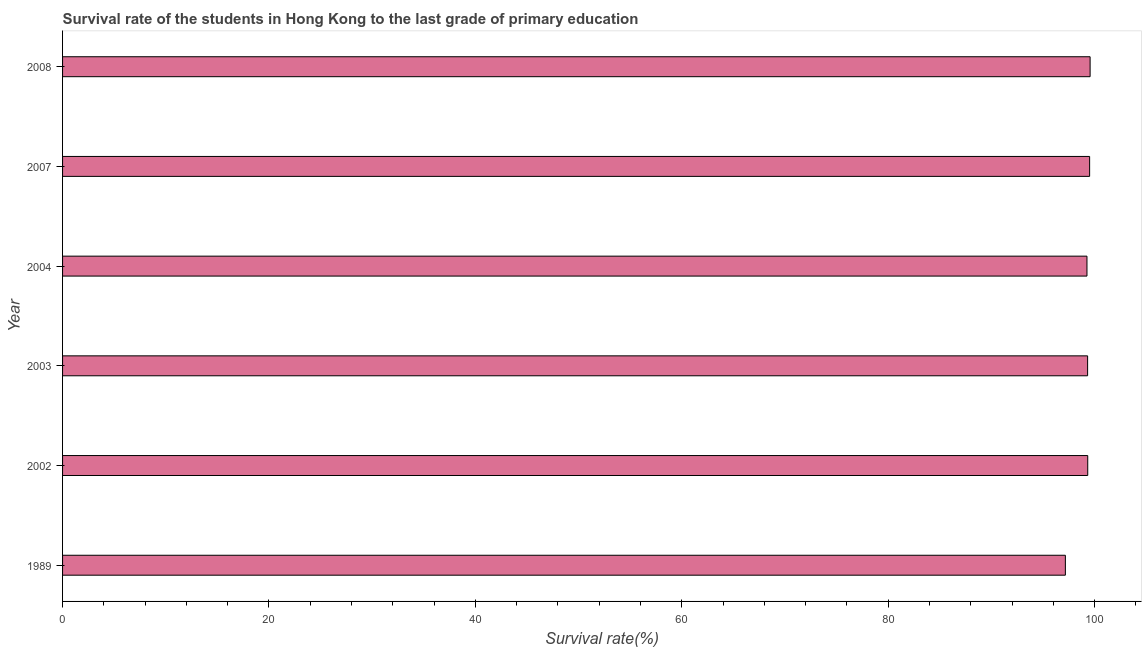Does the graph contain grids?
Provide a short and direct response. No. What is the title of the graph?
Offer a very short reply. Survival rate of the students in Hong Kong to the last grade of primary education. What is the label or title of the X-axis?
Your response must be concise. Survival rate(%). What is the survival rate in primary education in 2004?
Give a very brief answer. 99.26. Across all years, what is the maximum survival rate in primary education?
Offer a terse response. 99.56. Across all years, what is the minimum survival rate in primary education?
Your answer should be very brief. 97.16. In which year was the survival rate in primary education maximum?
Ensure brevity in your answer.  2008. What is the sum of the survival rate in primary education?
Ensure brevity in your answer.  594.14. What is the difference between the survival rate in primary education in 1989 and 2008?
Provide a succinct answer. -2.4. What is the average survival rate in primary education per year?
Make the answer very short. 99.02. What is the median survival rate in primary education?
Give a very brief answer. 99.32. Do a majority of the years between 2002 and 2007 (inclusive) have survival rate in primary education greater than 60 %?
Provide a short and direct response. Yes. What is the ratio of the survival rate in primary education in 1989 to that in 2004?
Provide a short and direct response. 0.98. Is the difference between the survival rate in primary education in 2003 and 2007 greater than the difference between any two years?
Offer a very short reply. No. What is the difference between the highest and the second highest survival rate in primary education?
Your answer should be very brief. 0.05. What is the difference between the highest and the lowest survival rate in primary education?
Provide a succinct answer. 2.4. How many bars are there?
Make the answer very short. 6. Are all the bars in the graph horizontal?
Offer a terse response. Yes. How many years are there in the graph?
Provide a short and direct response. 6. What is the difference between two consecutive major ticks on the X-axis?
Your answer should be very brief. 20. Are the values on the major ticks of X-axis written in scientific E-notation?
Offer a very short reply. No. What is the Survival rate(%) in 1989?
Give a very brief answer. 97.16. What is the Survival rate(%) of 2002?
Keep it short and to the point. 99.33. What is the Survival rate(%) of 2003?
Make the answer very short. 99.32. What is the Survival rate(%) in 2004?
Your answer should be very brief. 99.26. What is the Survival rate(%) in 2007?
Make the answer very short. 99.51. What is the Survival rate(%) of 2008?
Your response must be concise. 99.56. What is the difference between the Survival rate(%) in 1989 and 2002?
Your answer should be compact. -2.17. What is the difference between the Survival rate(%) in 1989 and 2003?
Offer a very short reply. -2.15. What is the difference between the Survival rate(%) in 1989 and 2004?
Offer a very short reply. -2.09. What is the difference between the Survival rate(%) in 1989 and 2007?
Make the answer very short. -2.35. What is the difference between the Survival rate(%) in 1989 and 2008?
Provide a short and direct response. -2.4. What is the difference between the Survival rate(%) in 2002 and 2003?
Offer a terse response. 0.01. What is the difference between the Survival rate(%) in 2002 and 2004?
Provide a short and direct response. 0.07. What is the difference between the Survival rate(%) in 2002 and 2007?
Provide a short and direct response. -0.18. What is the difference between the Survival rate(%) in 2002 and 2008?
Provide a short and direct response. -0.23. What is the difference between the Survival rate(%) in 2003 and 2004?
Offer a very short reply. 0.06. What is the difference between the Survival rate(%) in 2003 and 2007?
Your answer should be compact. -0.2. What is the difference between the Survival rate(%) in 2003 and 2008?
Your answer should be very brief. -0.24. What is the difference between the Survival rate(%) in 2004 and 2007?
Your response must be concise. -0.26. What is the difference between the Survival rate(%) in 2004 and 2008?
Provide a succinct answer. -0.3. What is the difference between the Survival rate(%) in 2007 and 2008?
Keep it short and to the point. -0.05. What is the ratio of the Survival rate(%) in 1989 to that in 2002?
Your answer should be very brief. 0.98. What is the ratio of the Survival rate(%) in 1989 to that in 2008?
Provide a succinct answer. 0.98. What is the ratio of the Survival rate(%) in 2002 to that in 2003?
Keep it short and to the point. 1. What is the ratio of the Survival rate(%) in 2002 to that in 2004?
Offer a terse response. 1. What is the ratio of the Survival rate(%) in 2003 to that in 2004?
Provide a short and direct response. 1. What is the ratio of the Survival rate(%) in 2003 to that in 2007?
Provide a succinct answer. 1. What is the ratio of the Survival rate(%) in 2003 to that in 2008?
Provide a succinct answer. 1. What is the ratio of the Survival rate(%) in 2004 to that in 2007?
Offer a terse response. 1. 